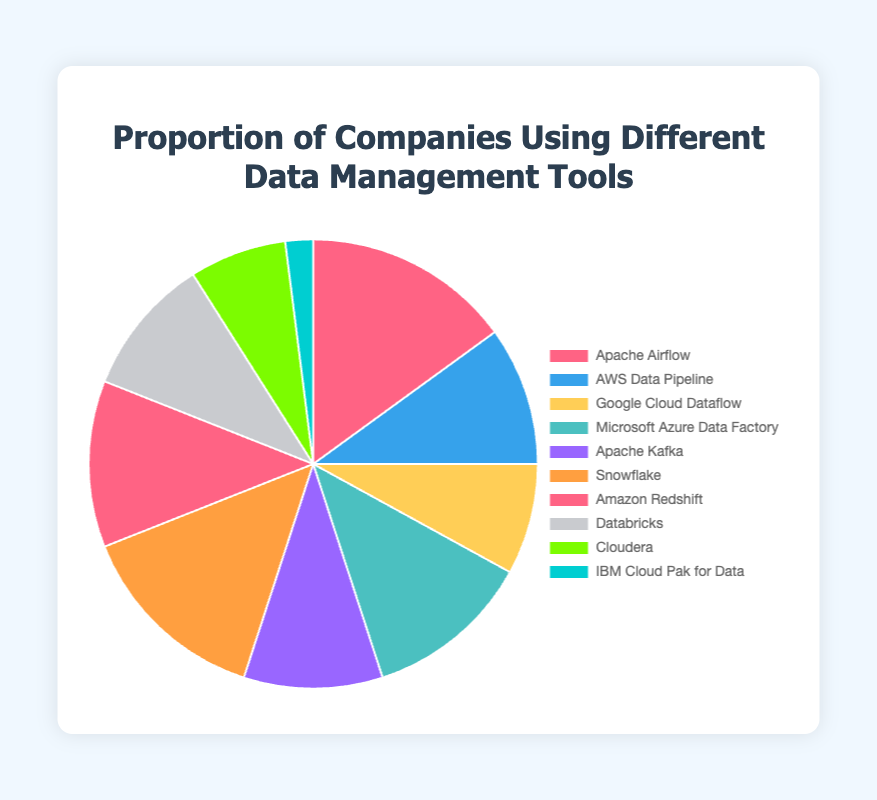What tool has the highest proportion of usage among companies? From the pie chart, we observe the segment with the highest value. By looking at the labels, we see that Apache Airflow has the highest value, with 15%.
Answer: Apache Airflow Which tools are used by exactly 10% of companies? Observing the pie chart, we can identify the segments or labels with a value of 10. These tools include AWS Data Pipeline, Apache Kafka, and Databricks.
Answer: AWS Data Pipeline, Apache Kafka, Databricks What is the difference in usage percentage between the most used tool and the least used tool? The most used tool is Apache Airflow at 15%, and the least used tool is IBM Cloud Pak for Data at 2%. Subtracting the two gives 15% - 2% = 13%.
Answer: 13% Identify the tools whose usage percentages are below 10%. From the visual, the segments with values less than 10% are Google Cloud Dataflow (8%), Cloudera (7%), and IBM Cloud Pak for Data (2%).
Answer: Google Cloud Dataflow, Cloudera, IBM Cloud Pak for Data What is the combined proportion of companies using either Snowflake or Amazon Redshift? Snowflake has 14% and Amazon Redshift has 12%. Adding these values, 14% + 12% = 26%.
Answer: 26% Which tool represented by blue is used by 10% of companies? By observing the color sequencing, we find the blue section corresponding to AWS Data Pipeline, which has a value of 10%.
Answer: AWS Data Pipeline If you group the tools into two categories: above 10% and below or equal to 10%, how many tools fall into each category? Segments above 10% include Apache Airflow, Microsoft Azure Data Factory, Snowflake, Amazon Redshift. Segments of 10% or below include AWS Data Pipeline, Google Cloud Dataflow, Apache Kafka, Databricks, Cloudera, IBM Cloud Pak for Data. This results in 4 in the first category and 6 in the second.
Answer: 4 and 6 Which tool has the percentage usage closest to that of Microsoft Azure Data Factory? Microsoft Azure Data Factory has a usage of 12%. Tools close to this value are Amazon Redshift (12%) and Snowflake (14%). Both are relatively close, but Amazon Redshift matches exactly, making it closest.
Answer: Amazon Redshift How many tools are represented by colors in shades of red? Visually detecting color shades, we observe that Apache Airflow (light red), Snowflake (orange-like red), and AWS Data Pipeline (bright red) are shades of red.
Answer: 3 